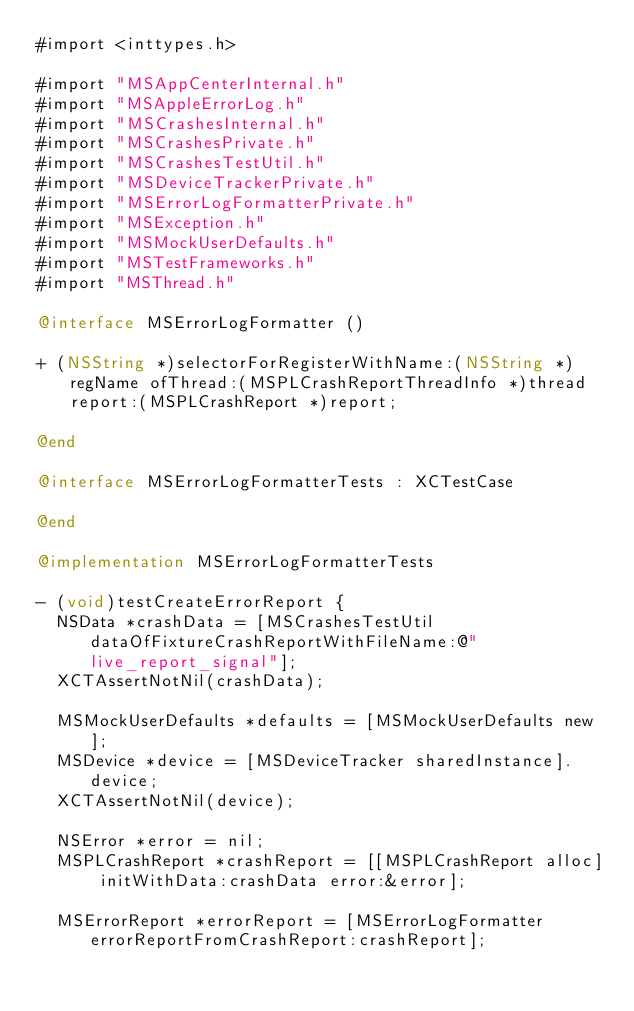Convert code to text. <code><loc_0><loc_0><loc_500><loc_500><_ObjectiveC_>#import <inttypes.h>

#import "MSAppCenterInternal.h"
#import "MSAppleErrorLog.h"
#import "MSCrashesInternal.h"
#import "MSCrashesPrivate.h"
#import "MSCrashesTestUtil.h"
#import "MSDeviceTrackerPrivate.h"
#import "MSErrorLogFormatterPrivate.h"
#import "MSException.h"
#import "MSMockUserDefaults.h"
#import "MSTestFrameworks.h"
#import "MSThread.h"

@interface MSErrorLogFormatter ()

+ (NSString *)selectorForRegisterWithName:(NSString *)regName ofThread:(MSPLCrashReportThreadInfo *)thread report:(MSPLCrashReport *)report;

@end

@interface MSErrorLogFormatterTests : XCTestCase

@end

@implementation MSErrorLogFormatterTests

- (void)testCreateErrorReport {
  NSData *crashData = [MSCrashesTestUtil dataOfFixtureCrashReportWithFileName:@"live_report_signal"];
  XCTAssertNotNil(crashData);

  MSMockUserDefaults *defaults = [MSMockUserDefaults new];
  MSDevice *device = [MSDeviceTracker sharedInstance].device;
  XCTAssertNotNil(device);

  NSError *error = nil;
  MSPLCrashReport *crashReport = [[MSPLCrashReport alloc] initWithData:crashData error:&error];

  MSErrorReport *errorReport = [MSErrorLogFormatter errorReportFromCrashReport:crashReport];</code> 